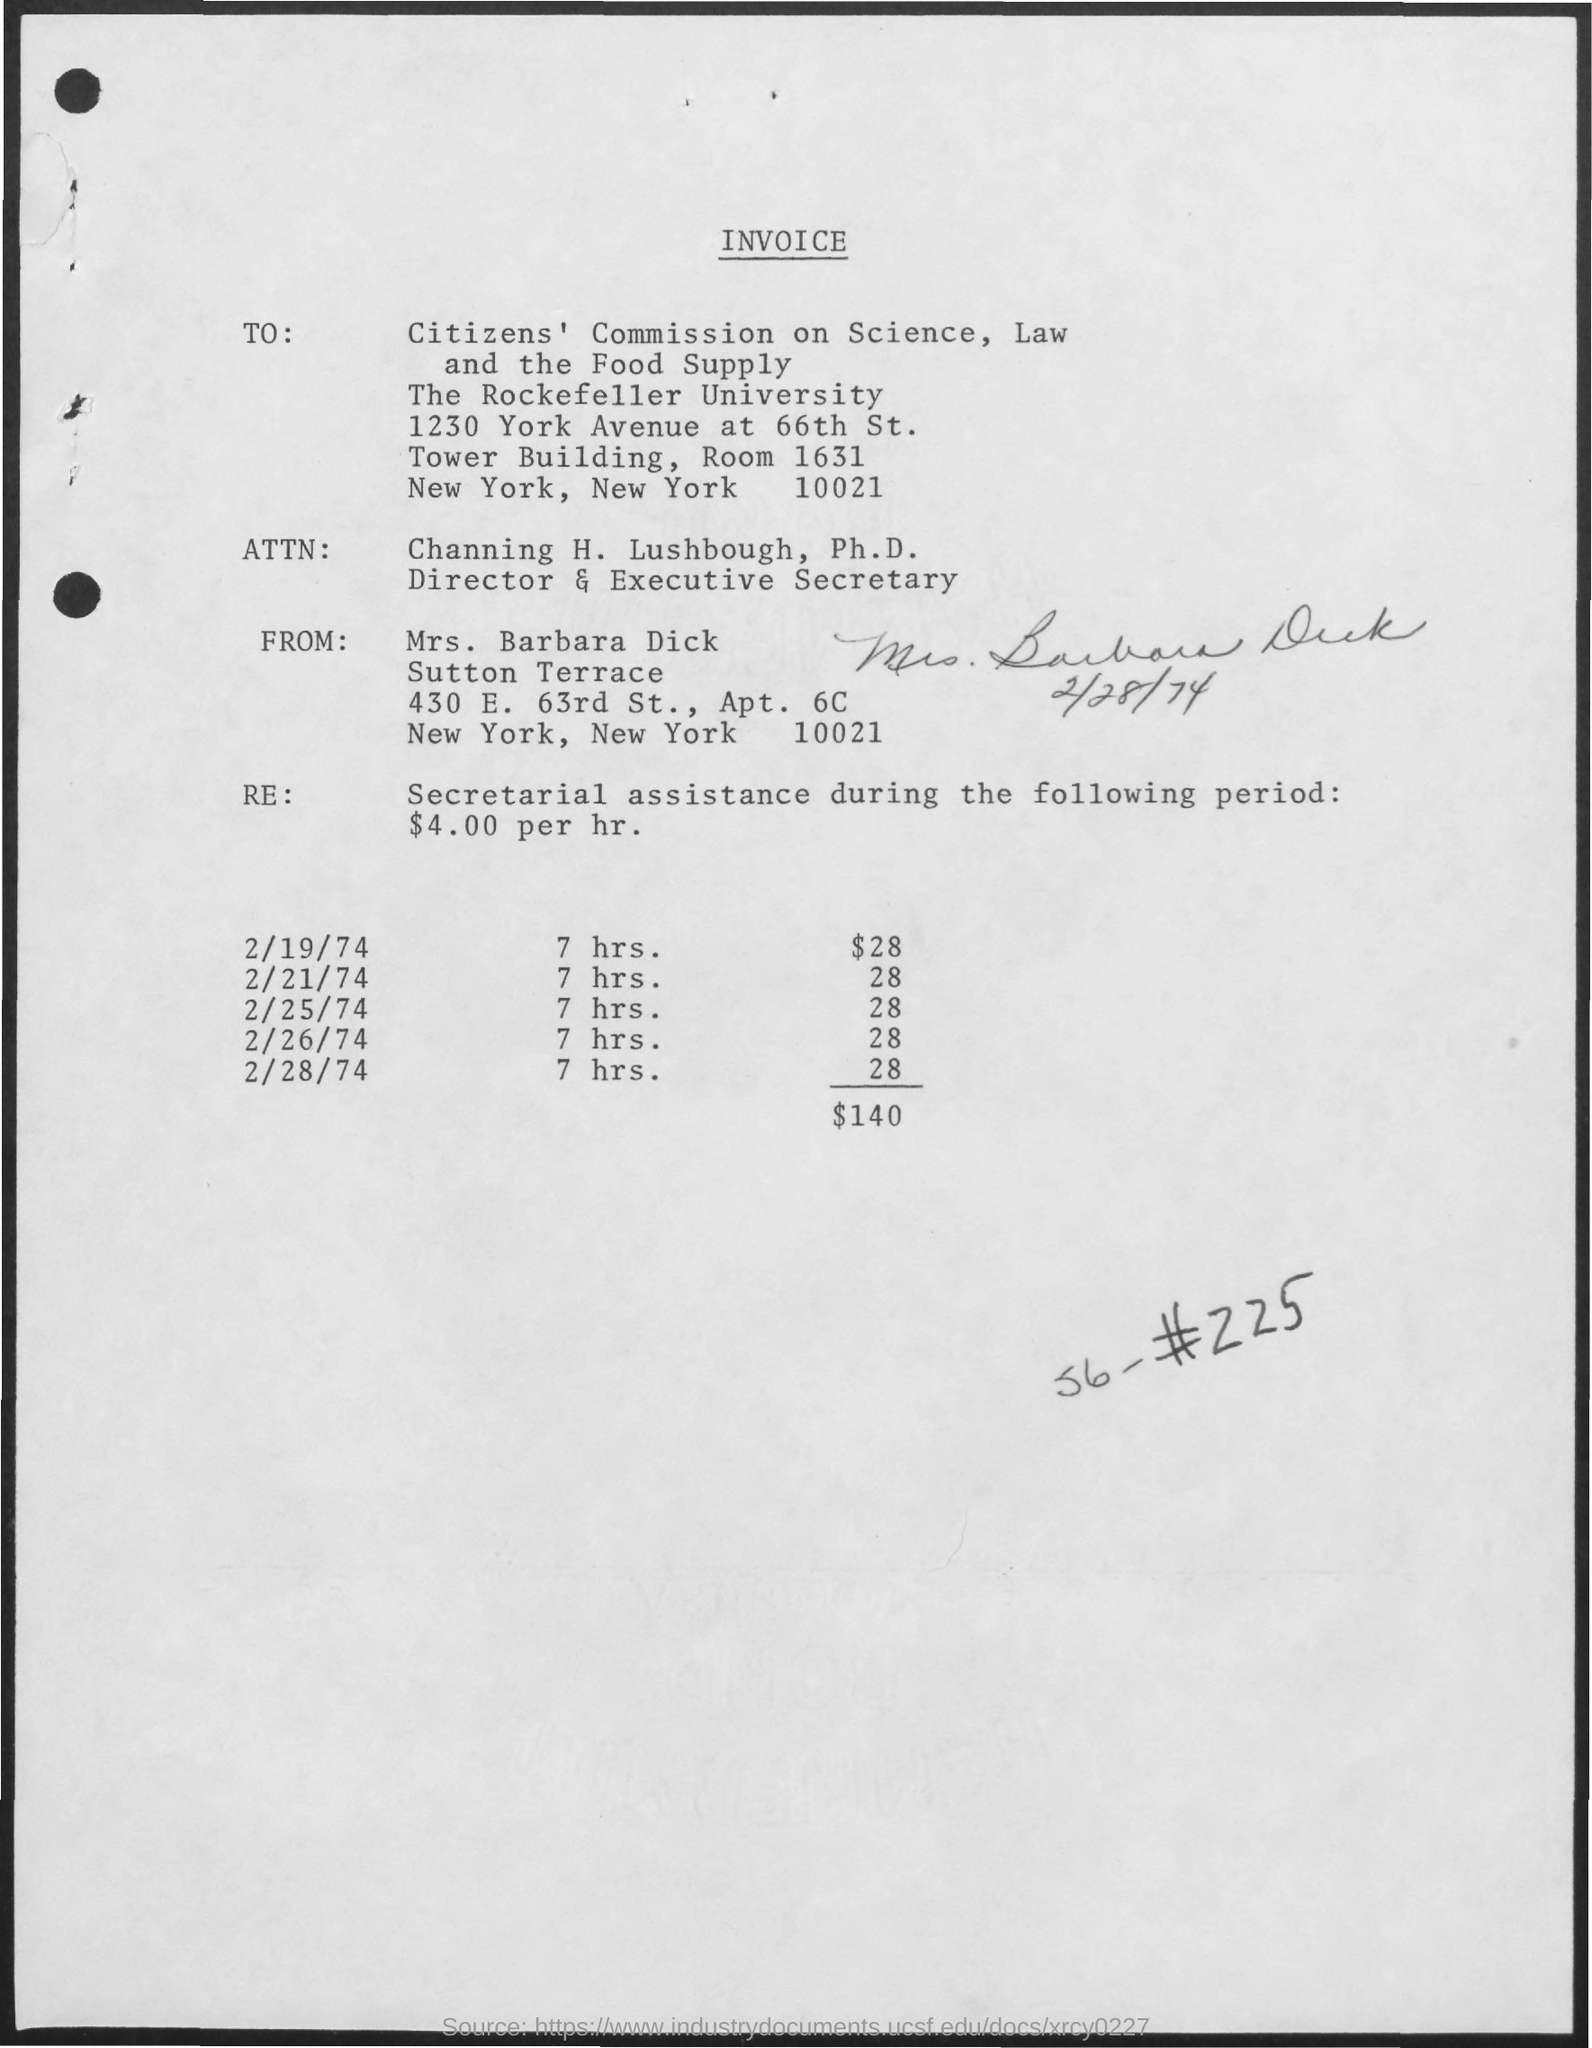from whom the invoice is delivered ?
 MRS. BARBARA DICK 